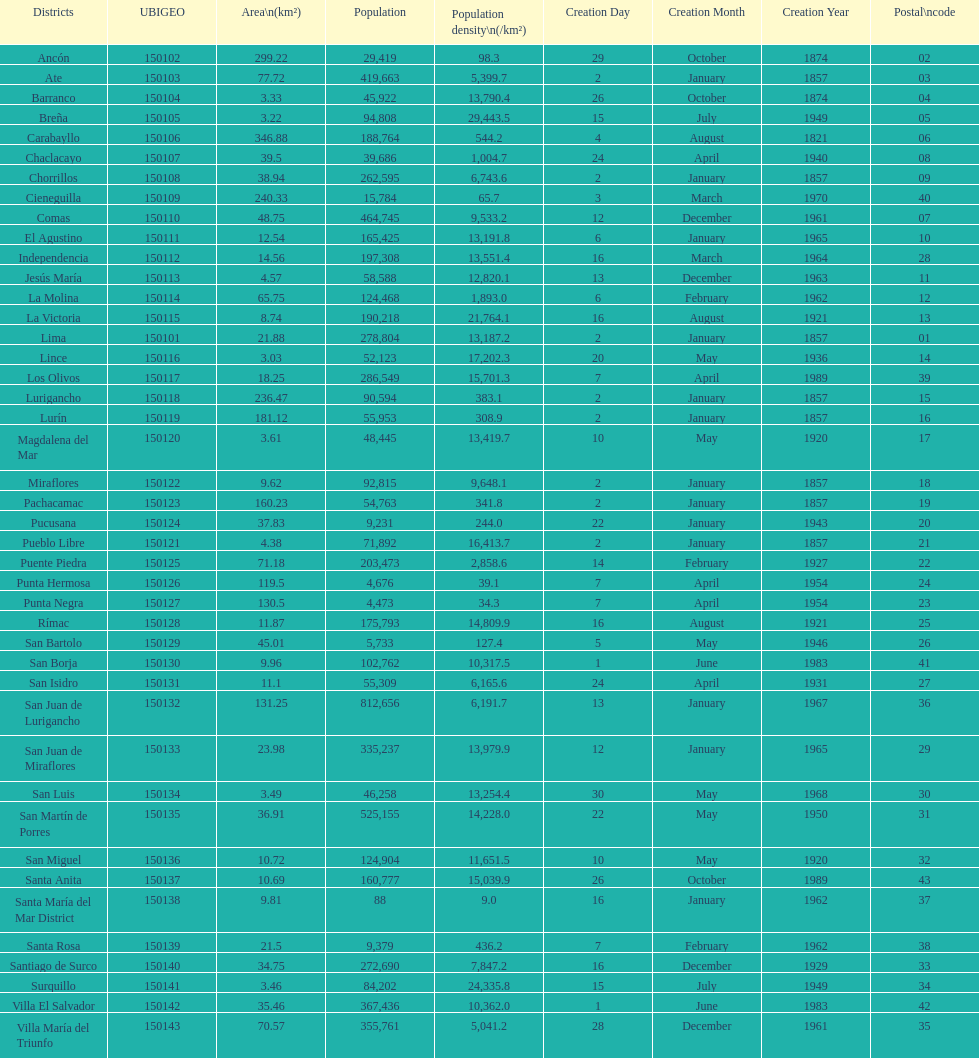What district has the least amount of population? Santa María del Mar District. 